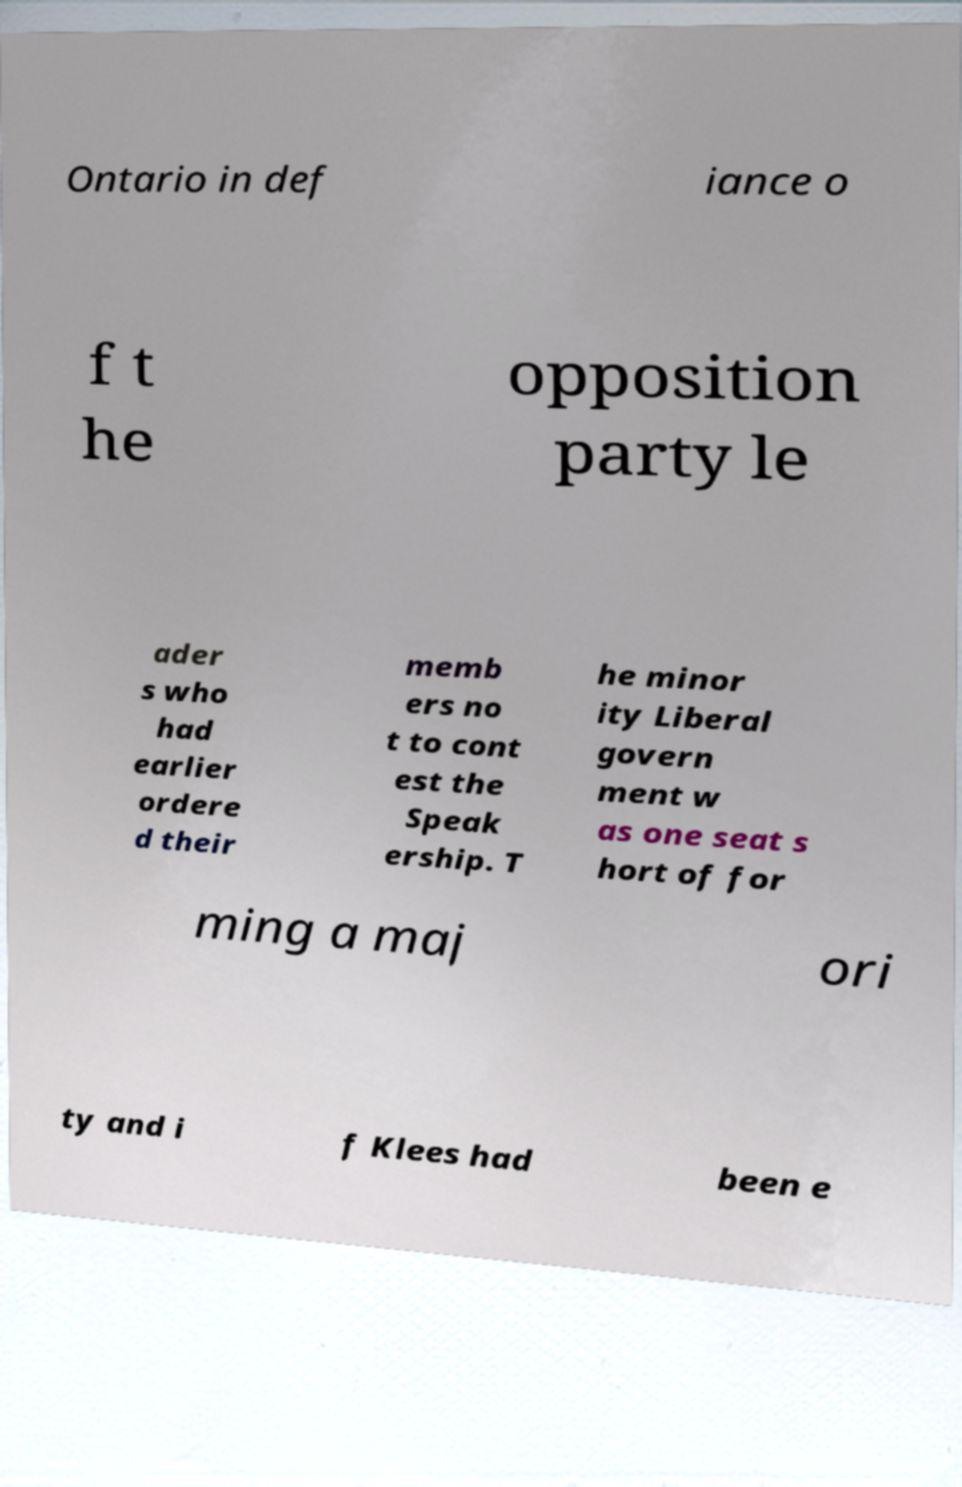Could you extract and type out the text from this image? Ontario in def iance o f t he opposition party le ader s who had earlier ordere d their memb ers no t to cont est the Speak ership. T he minor ity Liberal govern ment w as one seat s hort of for ming a maj ori ty and i f Klees had been e 